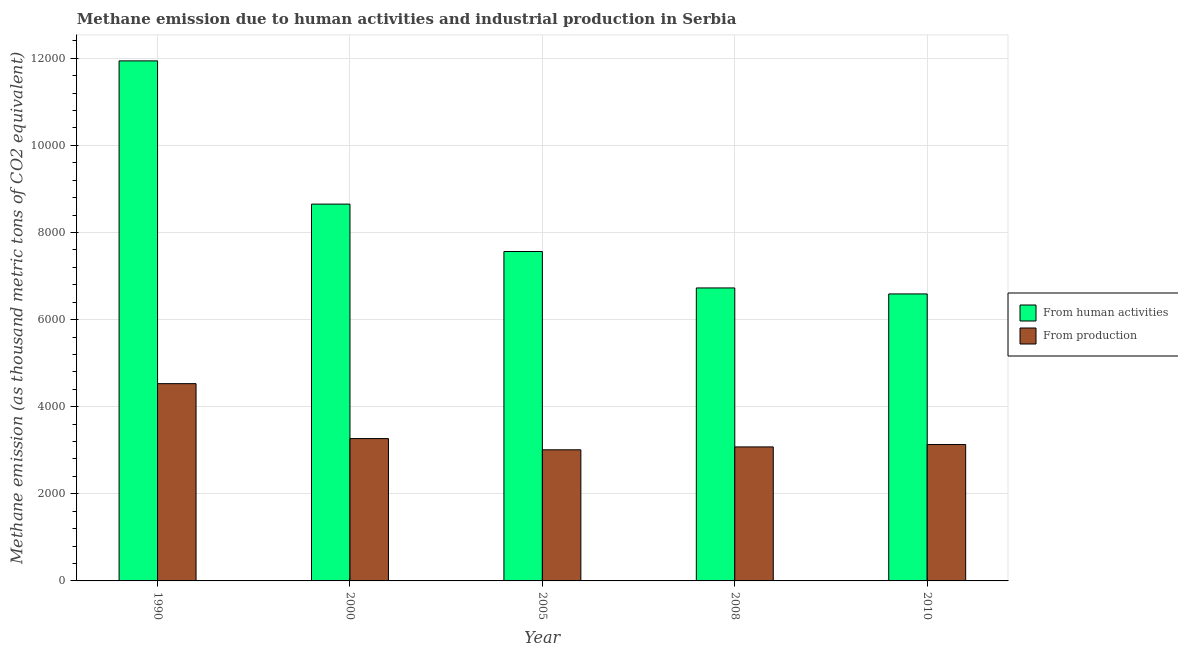How many bars are there on the 5th tick from the right?
Keep it short and to the point. 2. In how many cases, is the number of bars for a given year not equal to the number of legend labels?
Offer a very short reply. 0. What is the amount of emissions generated from industries in 1990?
Offer a very short reply. 4529.1. Across all years, what is the maximum amount of emissions generated from industries?
Give a very brief answer. 4529.1. Across all years, what is the minimum amount of emissions generated from industries?
Provide a succinct answer. 3010.4. In which year was the amount of emissions generated from industries maximum?
Provide a short and direct response. 1990. In which year was the amount of emissions from human activities minimum?
Ensure brevity in your answer.  2010. What is the total amount of emissions from human activities in the graph?
Offer a very short reply. 4.15e+04. What is the difference between the amount of emissions from human activities in 1990 and that in 2008?
Your answer should be compact. 5213.3. What is the difference between the amount of emissions generated from industries in 2005 and the amount of emissions from human activities in 2010?
Ensure brevity in your answer.  -121.3. What is the average amount of emissions generated from industries per year?
Your answer should be compact. 3403.1. What is the ratio of the amount of emissions generated from industries in 2005 to that in 2010?
Offer a very short reply. 0.96. Is the amount of emissions generated from industries in 1990 less than that in 2000?
Keep it short and to the point. No. Is the difference between the amount of emissions generated from industries in 1990 and 2005 greater than the difference between the amount of emissions from human activities in 1990 and 2005?
Your response must be concise. No. What is the difference between the highest and the second highest amount of emissions generated from industries?
Keep it short and to the point. 1261.4. What is the difference between the highest and the lowest amount of emissions from human activities?
Make the answer very short. 5350.7. In how many years, is the amount of emissions generated from industries greater than the average amount of emissions generated from industries taken over all years?
Make the answer very short. 1. Is the sum of the amount of emissions generated from industries in 2008 and 2010 greater than the maximum amount of emissions from human activities across all years?
Offer a very short reply. Yes. What does the 1st bar from the left in 2010 represents?
Your response must be concise. From human activities. What does the 1st bar from the right in 2008 represents?
Provide a succinct answer. From production. Are all the bars in the graph horizontal?
Ensure brevity in your answer.  No. How many years are there in the graph?
Keep it short and to the point. 5. What is the difference between two consecutive major ticks on the Y-axis?
Your response must be concise. 2000. Are the values on the major ticks of Y-axis written in scientific E-notation?
Offer a very short reply. No. Where does the legend appear in the graph?
Make the answer very short. Center right. How are the legend labels stacked?
Your answer should be compact. Vertical. What is the title of the graph?
Provide a succinct answer. Methane emission due to human activities and industrial production in Serbia. What is the label or title of the Y-axis?
Give a very brief answer. Methane emission (as thousand metric tons of CO2 equivalent). What is the Methane emission (as thousand metric tons of CO2 equivalent) in From human activities in 1990?
Your answer should be compact. 1.19e+04. What is the Methane emission (as thousand metric tons of CO2 equivalent) of From production in 1990?
Provide a succinct answer. 4529.1. What is the Methane emission (as thousand metric tons of CO2 equivalent) of From human activities in 2000?
Keep it short and to the point. 8650.9. What is the Methane emission (as thousand metric tons of CO2 equivalent) in From production in 2000?
Keep it short and to the point. 3267.7. What is the Methane emission (as thousand metric tons of CO2 equivalent) of From human activities in 2005?
Give a very brief answer. 7563. What is the Methane emission (as thousand metric tons of CO2 equivalent) of From production in 2005?
Offer a terse response. 3010.4. What is the Methane emission (as thousand metric tons of CO2 equivalent) in From human activities in 2008?
Provide a succinct answer. 6726.4. What is the Methane emission (as thousand metric tons of CO2 equivalent) of From production in 2008?
Provide a short and direct response. 3076.6. What is the Methane emission (as thousand metric tons of CO2 equivalent) in From human activities in 2010?
Ensure brevity in your answer.  6589. What is the Methane emission (as thousand metric tons of CO2 equivalent) of From production in 2010?
Give a very brief answer. 3131.7. Across all years, what is the maximum Methane emission (as thousand metric tons of CO2 equivalent) in From human activities?
Ensure brevity in your answer.  1.19e+04. Across all years, what is the maximum Methane emission (as thousand metric tons of CO2 equivalent) in From production?
Your answer should be compact. 4529.1. Across all years, what is the minimum Methane emission (as thousand metric tons of CO2 equivalent) of From human activities?
Your response must be concise. 6589. Across all years, what is the minimum Methane emission (as thousand metric tons of CO2 equivalent) of From production?
Your answer should be compact. 3010.4. What is the total Methane emission (as thousand metric tons of CO2 equivalent) of From human activities in the graph?
Give a very brief answer. 4.15e+04. What is the total Methane emission (as thousand metric tons of CO2 equivalent) of From production in the graph?
Offer a very short reply. 1.70e+04. What is the difference between the Methane emission (as thousand metric tons of CO2 equivalent) of From human activities in 1990 and that in 2000?
Provide a succinct answer. 3288.8. What is the difference between the Methane emission (as thousand metric tons of CO2 equivalent) in From production in 1990 and that in 2000?
Provide a short and direct response. 1261.4. What is the difference between the Methane emission (as thousand metric tons of CO2 equivalent) in From human activities in 1990 and that in 2005?
Your response must be concise. 4376.7. What is the difference between the Methane emission (as thousand metric tons of CO2 equivalent) in From production in 1990 and that in 2005?
Your answer should be very brief. 1518.7. What is the difference between the Methane emission (as thousand metric tons of CO2 equivalent) in From human activities in 1990 and that in 2008?
Your answer should be very brief. 5213.3. What is the difference between the Methane emission (as thousand metric tons of CO2 equivalent) in From production in 1990 and that in 2008?
Ensure brevity in your answer.  1452.5. What is the difference between the Methane emission (as thousand metric tons of CO2 equivalent) of From human activities in 1990 and that in 2010?
Your answer should be compact. 5350.7. What is the difference between the Methane emission (as thousand metric tons of CO2 equivalent) in From production in 1990 and that in 2010?
Make the answer very short. 1397.4. What is the difference between the Methane emission (as thousand metric tons of CO2 equivalent) in From human activities in 2000 and that in 2005?
Your answer should be compact. 1087.9. What is the difference between the Methane emission (as thousand metric tons of CO2 equivalent) of From production in 2000 and that in 2005?
Keep it short and to the point. 257.3. What is the difference between the Methane emission (as thousand metric tons of CO2 equivalent) in From human activities in 2000 and that in 2008?
Provide a short and direct response. 1924.5. What is the difference between the Methane emission (as thousand metric tons of CO2 equivalent) of From production in 2000 and that in 2008?
Your response must be concise. 191.1. What is the difference between the Methane emission (as thousand metric tons of CO2 equivalent) in From human activities in 2000 and that in 2010?
Make the answer very short. 2061.9. What is the difference between the Methane emission (as thousand metric tons of CO2 equivalent) in From production in 2000 and that in 2010?
Provide a succinct answer. 136. What is the difference between the Methane emission (as thousand metric tons of CO2 equivalent) of From human activities in 2005 and that in 2008?
Give a very brief answer. 836.6. What is the difference between the Methane emission (as thousand metric tons of CO2 equivalent) in From production in 2005 and that in 2008?
Offer a very short reply. -66.2. What is the difference between the Methane emission (as thousand metric tons of CO2 equivalent) in From human activities in 2005 and that in 2010?
Provide a short and direct response. 974. What is the difference between the Methane emission (as thousand metric tons of CO2 equivalent) of From production in 2005 and that in 2010?
Give a very brief answer. -121.3. What is the difference between the Methane emission (as thousand metric tons of CO2 equivalent) of From human activities in 2008 and that in 2010?
Keep it short and to the point. 137.4. What is the difference between the Methane emission (as thousand metric tons of CO2 equivalent) of From production in 2008 and that in 2010?
Give a very brief answer. -55.1. What is the difference between the Methane emission (as thousand metric tons of CO2 equivalent) of From human activities in 1990 and the Methane emission (as thousand metric tons of CO2 equivalent) of From production in 2000?
Your answer should be compact. 8672. What is the difference between the Methane emission (as thousand metric tons of CO2 equivalent) of From human activities in 1990 and the Methane emission (as thousand metric tons of CO2 equivalent) of From production in 2005?
Ensure brevity in your answer.  8929.3. What is the difference between the Methane emission (as thousand metric tons of CO2 equivalent) of From human activities in 1990 and the Methane emission (as thousand metric tons of CO2 equivalent) of From production in 2008?
Provide a succinct answer. 8863.1. What is the difference between the Methane emission (as thousand metric tons of CO2 equivalent) in From human activities in 1990 and the Methane emission (as thousand metric tons of CO2 equivalent) in From production in 2010?
Provide a succinct answer. 8808. What is the difference between the Methane emission (as thousand metric tons of CO2 equivalent) in From human activities in 2000 and the Methane emission (as thousand metric tons of CO2 equivalent) in From production in 2005?
Offer a very short reply. 5640.5. What is the difference between the Methane emission (as thousand metric tons of CO2 equivalent) of From human activities in 2000 and the Methane emission (as thousand metric tons of CO2 equivalent) of From production in 2008?
Give a very brief answer. 5574.3. What is the difference between the Methane emission (as thousand metric tons of CO2 equivalent) of From human activities in 2000 and the Methane emission (as thousand metric tons of CO2 equivalent) of From production in 2010?
Give a very brief answer. 5519.2. What is the difference between the Methane emission (as thousand metric tons of CO2 equivalent) in From human activities in 2005 and the Methane emission (as thousand metric tons of CO2 equivalent) in From production in 2008?
Your response must be concise. 4486.4. What is the difference between the Methane emission (as thousand metric tons of CO2 equivalent) of From human activities in 2005 and the Methane emission (as thousand metric tons of CO2 equivalent) of From production in 2010?
Make the answer very short. 4431.3. What is the difference between the Methane emission (as thousand metric tons of CO2 equivalent) in From human activities in 2008 and the Methane emission (as thousand metric tons of CO2 equivalent) in From production in 2010?
Make the answer very short. 3594.7. What is the average Methane emission (as thousand metric tons of CO2 equivalent) in From human activities per year?
Offer a terse response. 8293.8. What is the average Methane emission (as thousand metric tons of CO2 equivalent) of From production per year?
Keep it short and to the point. 3403.1. In the year 1990, what is the difference between the Methane emission (as thousand metric tons of CO2 equivalent) of From human activities and Methane emission (as thousand metric tons of CO2 equivalent) of From production?
Make the answer very short. 7410.6. In the year 2000, what is the difference between the Methane emission (as thousand metric tons of CO2 equivalent) in From human activities and Methane emission (as thousand metric tons of CO2 equivalent) in From production?
Make the answer very short. 5383.2. In the year 2005, what is the difference between the Methane emission (as thousand metric tons of CO2 equivalent) in From human activities and Methane emission (as thousand metric tons of CO2 equivalent) in From production?
Give a very brief answer. 4552.6. In the year 2008, what is the difference between the Methane emission (as thousand metric tons of CO2 equivalent) in From human activities and Methane emission (as thousand metric tons of CO2 equivalent) in From production?
Keep it short and to the point. 3649.8. In the year 2010, what is the difference between the Methane emission (as thousand metric tons of CO2 equivalent) of From human activities and Methane emission (as thousand metric tons of CO2 equivalent) of From production?
Your response must be concise. 3457.3. What is the ratio of the Methane emission (as thousand metric tons of CO2 equivalent) in From human activities in 1990 to that in 2000?
Your answer should be very brief. 1.38. What is the ratio of the Methane emission (as thousand metric tons of CO2 equivalent) of From production in 1990 to that in 2000?
Offer a terse response. 1.39. What is the ratio of the Methane emission (as thousand metric tons of CO2 equivalent) in From human activities in 1990 to that in 2005?
Make the answer very short. 1.58. What is the ratio of the Methane emission (as thousand metric tons of CO2 equivalent) of From production in 1990 to that in 2005?
Your response must be concise. 1.5. What is the ratio of the Methane emission (as thousand metric tons of CO2 equivalent) in From human activities in 1990 to that in 2008?
Give a very brief answer. 1.78. What is the ratio of the Methane emission (as thousand metric tons of CO2 equivalent) in From production in 1990 to that in 2008?
Give a very brief answer. 1.47. What is the ratio of the Methane emission (as thousand metric tons of CO2 equivalent) of From human activities in 1990 to that in 2010?
Ensure brevity in your answer.  1.81. What is the ratio of the Methane emission (as thousand metric tons of CO2 equivalent) in From production in 1990 to that in 2010?
Provide a short and direct response. 1.45. What is the ratio of the Methane emission (as thousand metric tons of CO2 equivalent) in From human activities in 2000 to that in 2005?
Give a very brief answer. 1.14. What is the ratio of the Methane emission (as thousand metric tons of CO2 equivalent) in From production in 2000 to that in 2005?
Ensure brevity in your answer.  1.09. What is the ratio of the Methane emission (as thousand metric tons of CO2 equivalent) of From human activities in 2000 to that in 2008?
Keep it short and to the point. 1.29. What is the ratio of the Methane emission (as thousand metric tons of CO2 equivalent) of From production in 2000 to that in 2008?
Your response must be concise. 1.06. What is the ratio of the Methane emission (as thousand metric tons of CO2 equivalent) of From human activities in 2000 to that in 2010?
Offer a terse response. 1.31. What is the ratio of the Methane emission (as thousand metric tons of CO2 equivalent) of From production in 2000 to that in 2010?
Your response must be concise. 1.04. What is the ratio of the Methane emission (as thousand metric tons of CO2 equivalent) of From human activities in 2005 to that in 2008?
Make the answer very short. 1.12. What is the ratio of the Methane emission (as thousand metric tons of CO2 equivalent) in From production in 2005 to that in 2008?
Make the answer very short. 0.98. What is the ratio of the Methane emission (as thousand metric tons of CO2 equivalent) in From human activities in 2005 to that in 2010?
Provide a short and direct response. 1.15. What is the ratio of the Methane emission (as thousand metric tons of CO2 equivalent) in From production in 2005 to that in 2010?
Your answer should be very brief. 0.96. What is the ratio of the Methane emission (as thousand metric tons of CO2 equivalent) in From human activities in 2008 to that in 2010?
Ensure brevity in your answer.  1.02. What is the ratio of the Methane emission (as thousand metric tons of CO2 equivalent) in From production in 2008 to that in 2010?
Your response must be concise. 0.98. What is the difference between the highest and the second highest Methane emission (as thousand metric tons of CO2 equivalent) of From human activities?
Keep it short and to the point. 3288.8. What is the difference between the highest and the second highest Methane emission (as thousand metric tons of CO2 equivalent) of From production?
Provide a succinct answer. 1261.4. What is the difference between the highest and the lowest Methane emission (as thousand metric tons of CO2 equivalent) of From human activities?
Ensure brevity in your answer.  5350.7. What is the difference between the highest and the lowest Methane emission (as thousand metric tons of CO2 equivalent) in From production?
Offer a very short reply. 1518.7. 